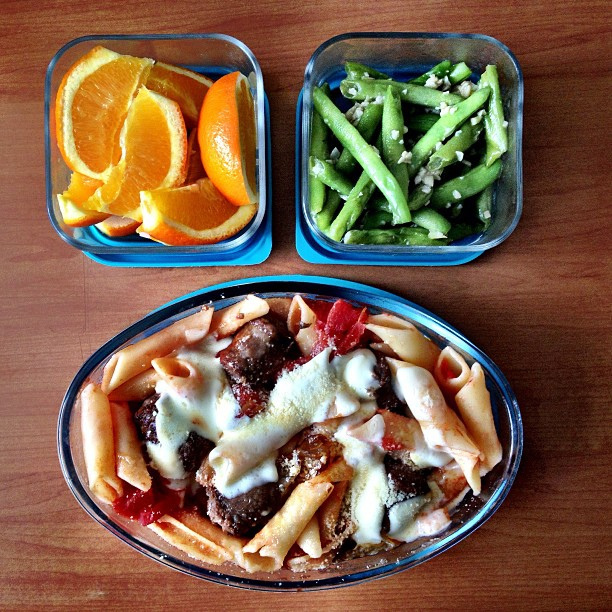Are there any allergens that could be of concern in the meal shown? Potential allergens include gluten from the pasta, dairy if cheese is used in the sauce or as a topping, and possibly nuts if they're included in the meatball recipe. Those with a citrus allergy should also be cautious of the orange slices. 